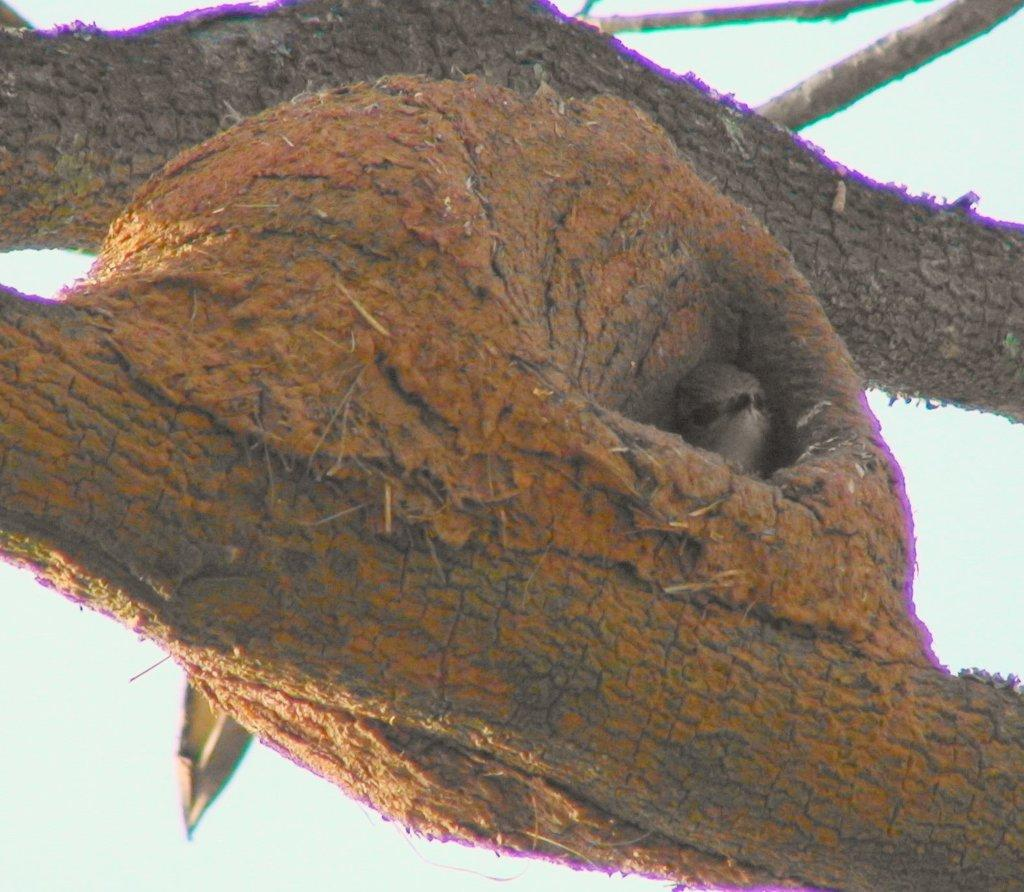What is the main subject of the image? The main subject of the image is a tree bark. Are there any additional features on the tree bark? Yes, there is a bird's nest on the tree bark. What type of work is being done in the prison depicted in the image? There is no prison present in the image; it is a zoom-in of a tree bark with a bird's nest. What kind of shoe can be seen on the tree bark in the image? There are no shoes present in the image; it is a close-up of a tree bark with a bird's nest. 